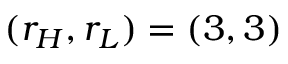Convert formula to latex. <formula><loc_0><loc_0><loc_500><loc_500>( r _ { H } , r _ { L } ) = ( 3 , 3 )</formula> 